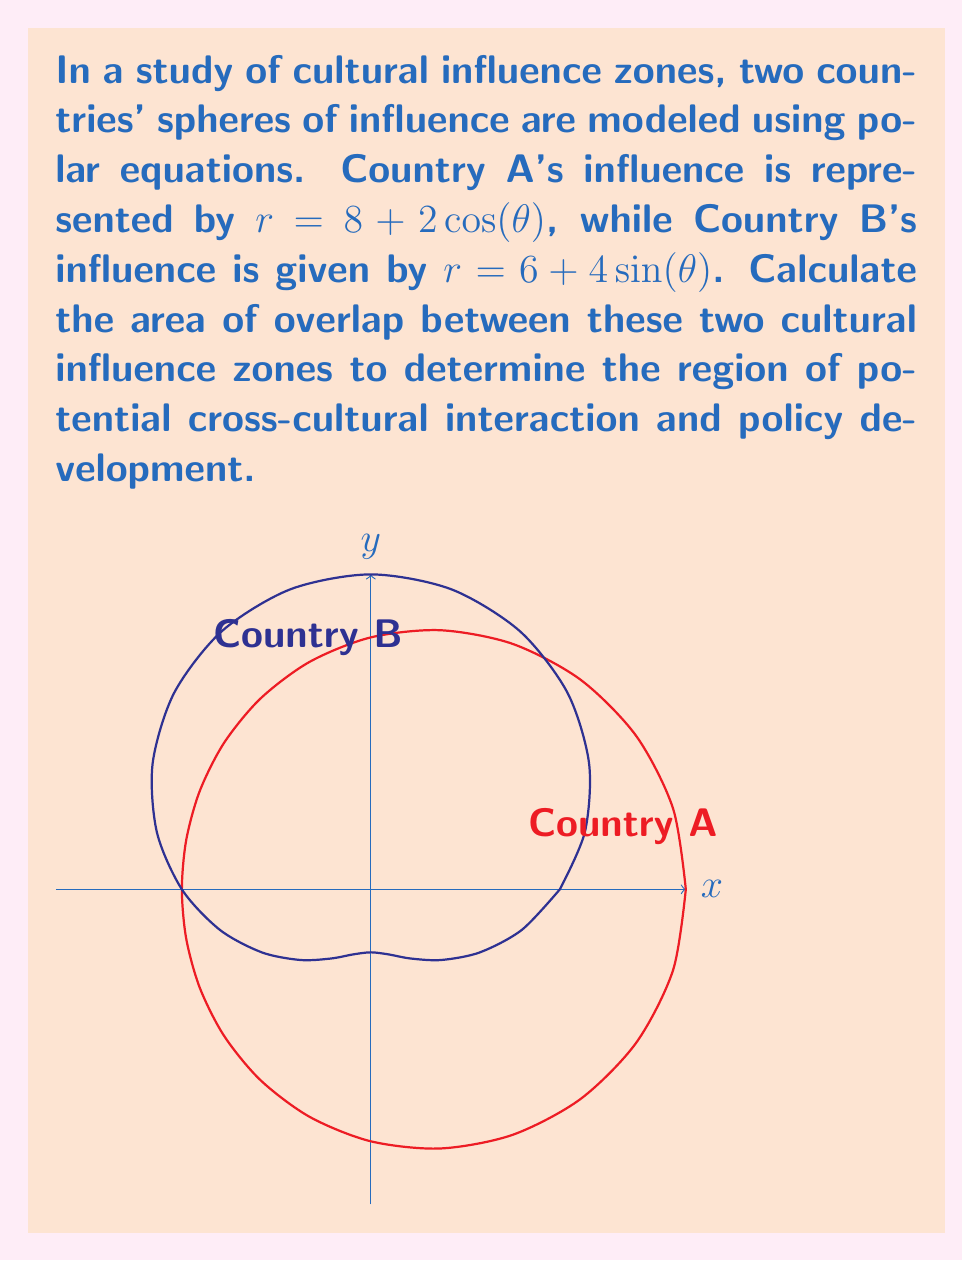Can you answer this question? To find the area of overlap, we need to follow these steps:

1) First, find the points of intersection of the two curves:
   $8 + 2\cos(\theta) = 6 + 4\sin(\theta)$
   $2 + 2\cos(\theta) = 4\sin(\theta)$
   $1 + \cos(\theta) = 2\sin(\theta)$
   
   Squaring both sides:
   $(1 + \cos(\theta))^2 = 4\sin^2(\theta)$
   $1 + 2\cos(\theta) + \cos^2(\theta) = 4(1-\cos^2(\theta))$
   $5\cos^2(\theta) + 2\cos(\theta) - 3 = 0$
   
   Solving this quadratic in $\cos(\theta)$:
   $\cos(\theta) = \frac{-1 \pm \sqrt{4 + 15}}{5} = \frac{-1 \pm 2\sqrt{19}}{5}$
   
   The valid solution is: $\cos(\theta) = \frac{-1 + 2\sqrt{19}}{5}$
   
   $\theta_1 = \arccos(\frac{-1 + 2\sqrt{19}}{5}) \approx 0.5890$ radians
   $\theta_2 = 2\pi - \theta_1 \approx 5.6942$ radians

2) The area of overlap is the difference between the areas enclosed by each curve between these two angles, which can be calculated using the formula:

   $A = \frac{1}{2} \int_{\theta_1}^{\theta_2} (r_1^2 - r_2^2) d\theta$

   Where $r_1 = 8 + 2\cos(\theta)$ and $r_2 = 6 + 4\sin(\theta)$

3) Expanding the integrand:
   $r_1^2 - r_2^2 = (8 + 2\cos(\theta))^2 - (6 + 4\sin(\theta))^2$
   $= 64 + 32\cos(\theta) + 4\cos^2(\theta) - 36 - 48\sin(\theta) - 16\sin^2(\theta)$
   $= 28 + 32\cos(\theta) - 48\sin(\theta) + 4\cos^2(\theta) - 16(1-\cos^2(\theta))$
   $= 12 + 32\cos(\theta) - 48\sin(\theta) + 20\cos^2(\theta)$

4) Integrating:
   $A = \frac{1}{2} \int_{\theta_1}^{\theta_2} (12 + 32\cos(\theta) - 48\sin(\theta) + 20\cos^2(\theta)) d\theta$
   
   $= \frac{1}{2} [12\theta + 32\sin(\theta) + 48\cos(\theta) + 10\theta + 5\sin(2\theta)]_{\theta_1}^{\theta_2}$

5) Evaluating at the limits and simplifying:
   $A \approx 31.4159$ square units

This area represents the region where the two cultural influence zones overlap, indicating potential for cross-cultural interaction and policy development.
Answer: $31.4159$ square units 